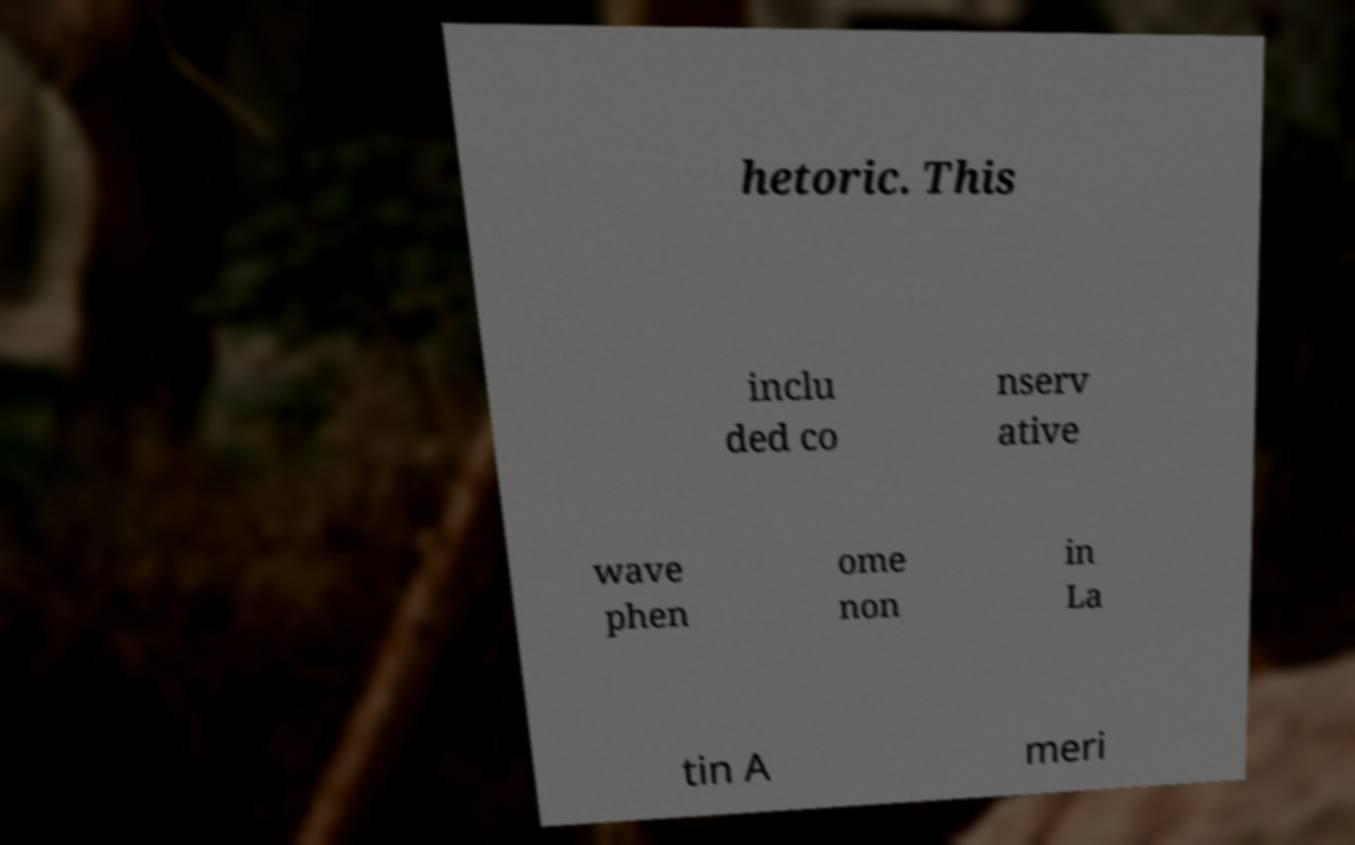Can you accurately transcribe the text from the provided image for me? hetoric. This inclu ded co nserv ative wave phen ome non in La tin A meri 